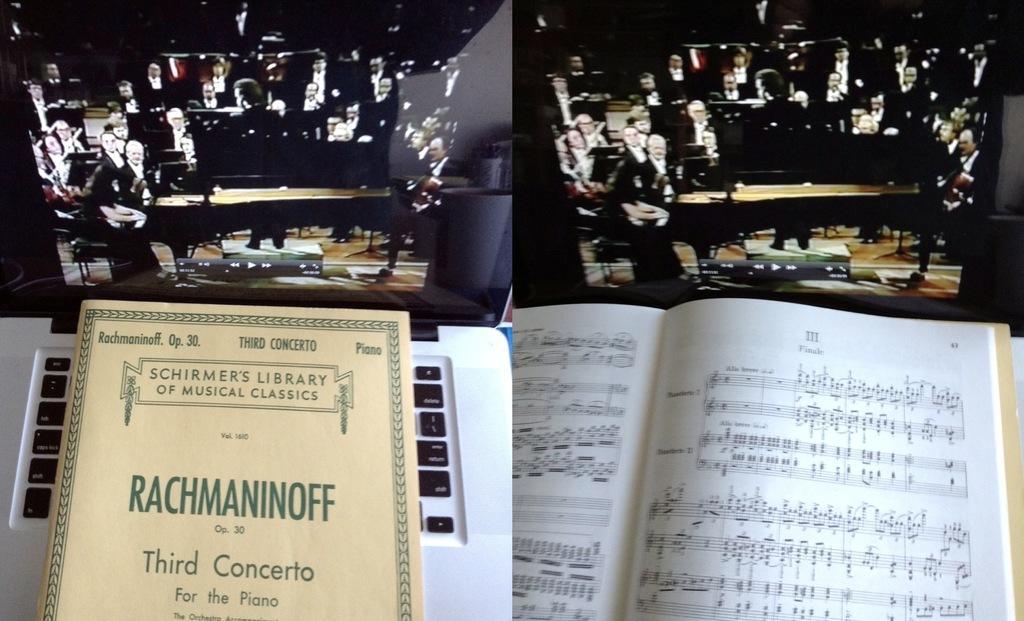In one or two sentences, can you explain what this image depicts? This is collage image. In this image there are books. There are people. 